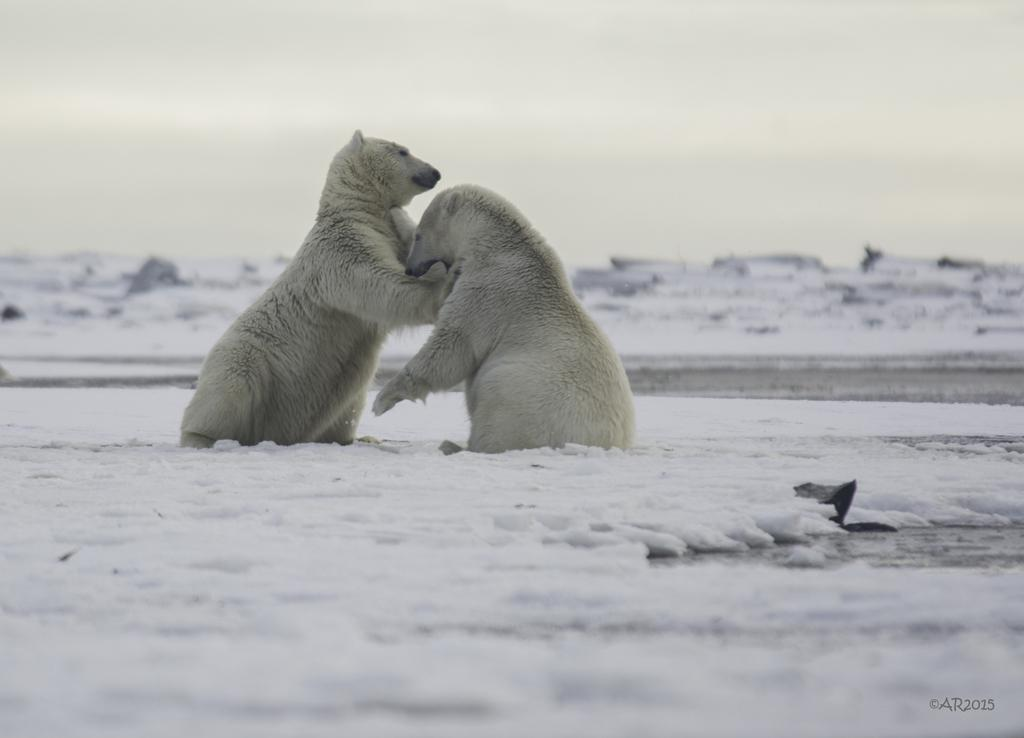How many polar bears are in the image? There are two polar bears in the image. What is the terrain like where the polar bears are located? The polar bears are on a snowy land. What can be seen in the background of the image? The sky is visible in the background of the image. What type of bubble can be seen in the image? There is no bubble present in the image. Is there a hospital visible in the image? No, there is no hospital present in the image. 